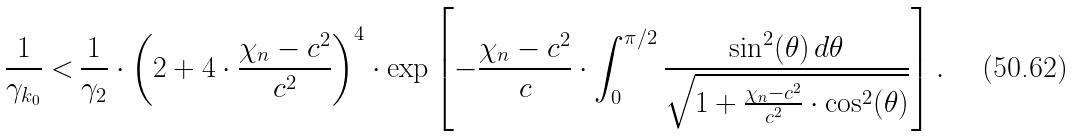Convert formula to latex. <formula><loc_0><loc_0><loc_500><loc_500>\frac { 1 } { \gamma _ { k _ { 0 } } } < & \, \frac { 1 } { \gamma _ { 2 } } \cdot \left ( 2 + 4 \cdot \frac { \chi _ { n } - c ^ { 2 } } { c ^ { 2 } } \right ) ^ { 4 } \cdot \exp \left [ - \frac { \chi _ { n } - c ^ { 2 } } { c } \cdot \int _ { 0 } ^ { \pi / 2 } \frac { \sin ^ { 2 } ( \theta ) \, d \theta } { \sqrt { 1 + \frac { \chi _ { n } - c ^ { 2 } } { c ^ { 2 } } \cdot \cos ^ { 2 } ( \theta ) } } \right ] .</formula> 